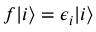<formula> <loc_0><loc_0><loc_500><loc_500>\begin{array} { r } { f | i \rangle = \epsilon _ { i } | i \rangle } \end{array}</formula> 